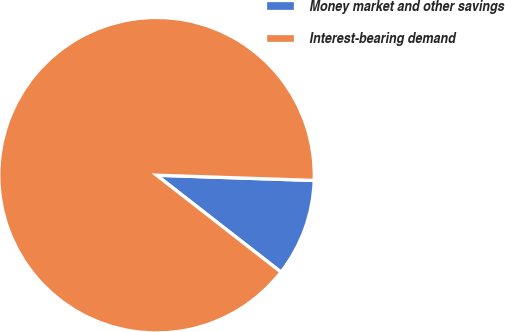Convert chart to OTSL. <chart><loc_0><loc_0><loc_500><loc_500><pie_chart><fcel>Money market and other savings<fcel>Interest-bearing demand<nl><fcel>10.0%<fcel>90.0%<nl></chart> 